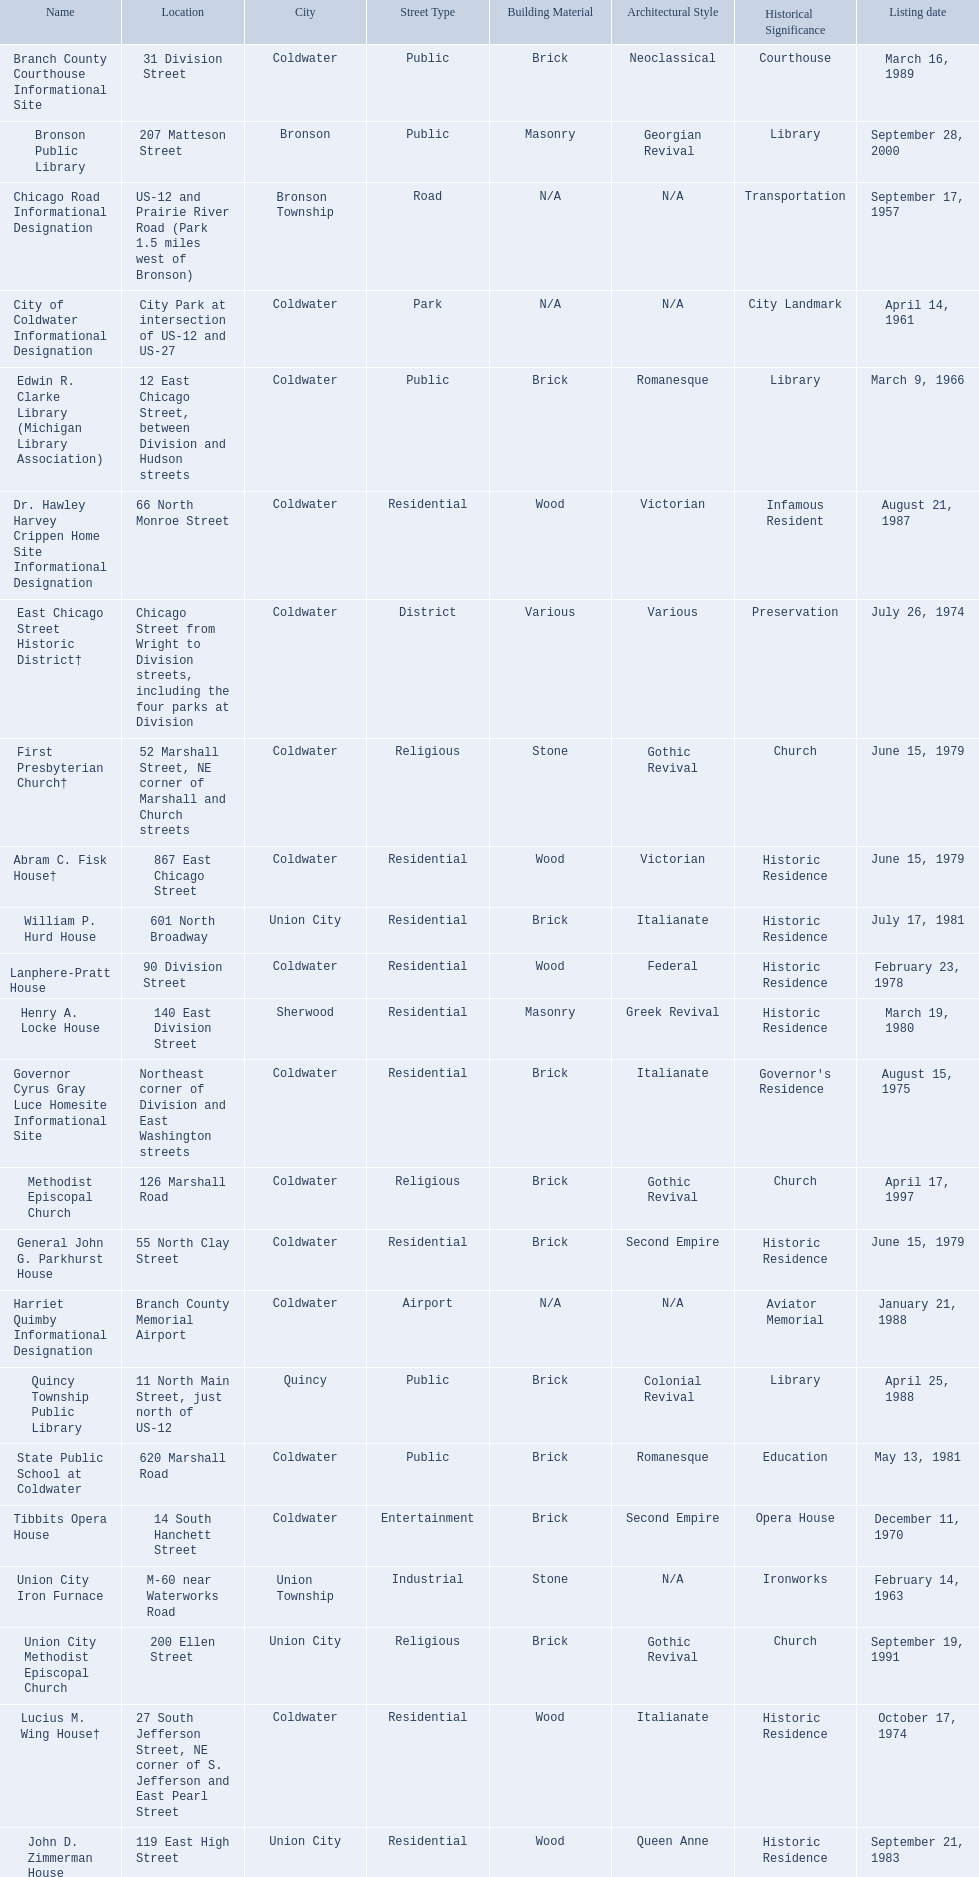Can you give me this table as a dict? {'header': ['Name', 'Location', 'City', 'Street Type', 'Building Material', 'Architectural Style', 'Historical Significance', 'Listing date'], 'rows': [['Branch County Courthouse Informational Site', '31 Division Street', 'Coldwater', 'Public', 'Brick', 'Neoclassical', 'Courthouse', 'March 16, 1989'], ['Bronson Public Library', '207 Matteson Street', 'Bronson', 'Public', 'Masonry', 'Georgian Revival', 'Library', 'September 28, 2000'], ['Chicago Road Informational Designation', 'US-12 and Prairie River Road (Park 1.5 miles west of Bronson)', 'Bronson Township', 'Road', 'N/A', 'N/A', 'Transportation', 'September 17, 1957'], ['City of Coldwater Informational Designation', 'City Park at intersection of US-12 and US-27', 'Coldwater', 'Park', 'N/A', 'N/A', 'City Landmark', 'April 14, 1961'], ['Edwin R. Clarke Library (Michigan Library Association)', '12 East Chicago Street, between Division and Hudson streets', 'Coldwater', 'Public', 'Brick', 'Romanesque', 'Library', 'March 9, 1966'], ['Dr. Hawley Harvey Crippen Home Site Informational Designation', '66 North Monroe Street', 'Coldwater', 'Residential', 'Wood', 'Victorian', 'Infamous Resident', 'August 21, 1987'], ['East Chicago Street Historic District†', 'Chicago Street from Wright to Division streets, including the four parks at Division', 'Coldwater', 'District', 'Various', 'Various', 'Preservation', 'July 26, 1974'], ['First Presbyterian Church†', '52 Marshall Street, NE corner of Marshall and Church streets', 'Coldwater', 'Religious', 'Stone', 'Gothic Revival', 'Church', 'June 15, 1979'], ['Abram C. Fisk House†', '867 East Chicago Street', 'Coldwater', 'Residential', 'Wood', 'Victorian', 'Historic Residence', 'June 15, 1979'], ['William P. Hurd House', '601 North Broadway', 'Union City', 'Residential', 'Brick', 'Italianate', 'Historic Residence', 'July 17, 1981'], ['Lanphere-Pratt House', '90 Division Street', 'Coldwater', 'Residential', 'Wood', 'Federal', 'Historic Residence', 'February 23, 1978'], ['Henry A. Locke House', '140 East Division Street', 'Sherwood', 'Residential', 'Masonry', 'Greek Revival', 'Historic Residence', 'March 19, 1980'], ['Governor Cyrus Gray Luce Homesite Informational Site', 'Northeast corner of Division and East Washington streets', 'Coldwater', 'Residential', 'Brick', 'Italianate', "Governor's Residence", 'August 15, 1975'], ['Methodist Episcopal Church', '126 Marshall Road', 'Coldwater', 'Religious', 'Brick', 'Gothic Revival', 'Church', 'April 17, 1997'], ['General John G. Parkhurst House', '55 North Clay Street', 'Coldwater', 'Residential', 'Brick', 'Second Empire', 'Historic Residence', 'June 15, 1979'], ['Harriet Quimby Informational Designation', 'Branch County Memorial Airport', 'Coldwater', 'Airport', 'N/A', 'N/A', 'Aviator Memorial', 'January 21, 1988'], ['Quincy Township Public Library', '11 North Main Street, just north of US-12', 'Quincy', 'Public', 'Brick', 'Colonial Revival', 'Library', 'April 25, 1988'], ['State Public School at Coldwater', '620 Marshall Road', 'Coldwater', 'Public', 'Brick', 'Romanesque', 'Education', 'May 13, 1981'], ['Tibbits Opera House', '14 South Hanchett Street', 'Coldwater', 'Entertainment', 'Brick', 'Second Empire', 'Opera House', 'December 11, 1970'], ['Union City Iron Furnace', 'M-60 near Waterworks Road', 'Union Township', 'Industrial', 'Stone', 'N/A', 'Ironworks', 'February 14, 1963'], ['Union City Methodist Episcopal Church', '200 Ellen Street', 'Union City', 'Religious', 'Brick', 'Gothic Revival', 'Church', 'September 19, 1991'], ['Lucius M. Wing House†', '27 South Jefferson Street, NE corner of S. Jefferson and East Pearl Street', 'Coldwater', 'Residential', 'Wood', 'Italianate', 'Historic Residence', 'October 17, 1974'], ['John D. Zimmerman House', '119 East High Street', 'Union City', 'Residential', 'Wood', 'Queen Anne', 'Historic Residence', 'September 21, 1983']]} Are there any listing dates that happened before 1960? September 17, 1957. What is the name of the site that was listed before 1960? Chicago Road Informational Designation. 